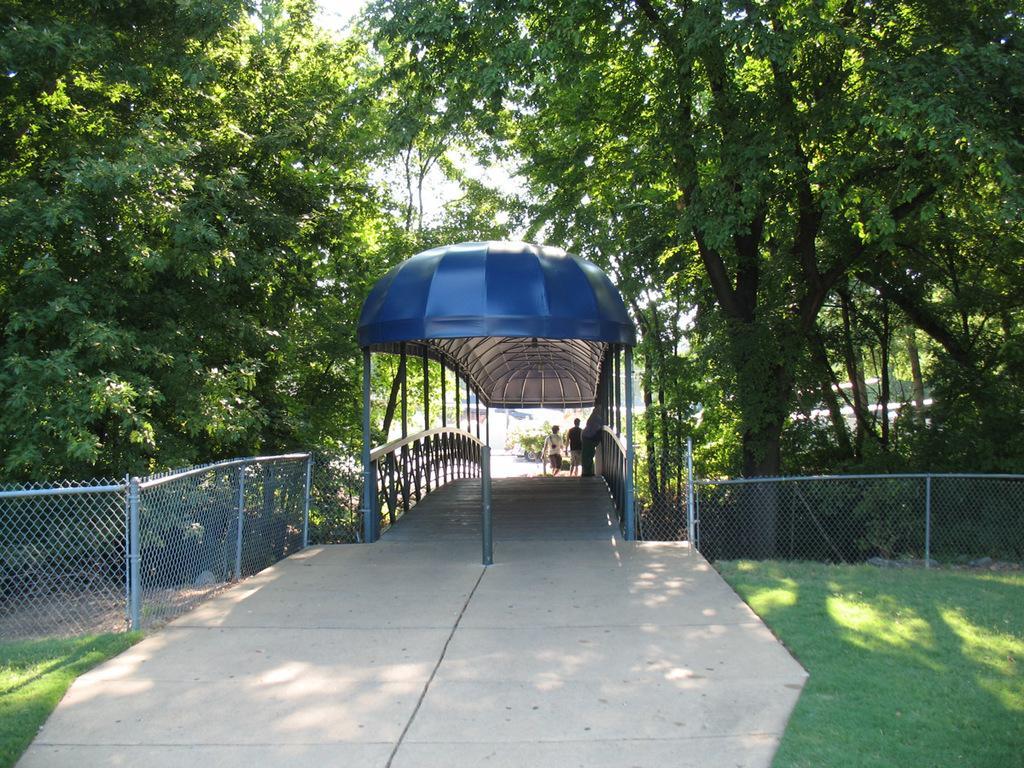In one or two sentences, can you explain what this image depicts? In this image in the middle, there are two people, trees, fence, grass, ground and sky. 